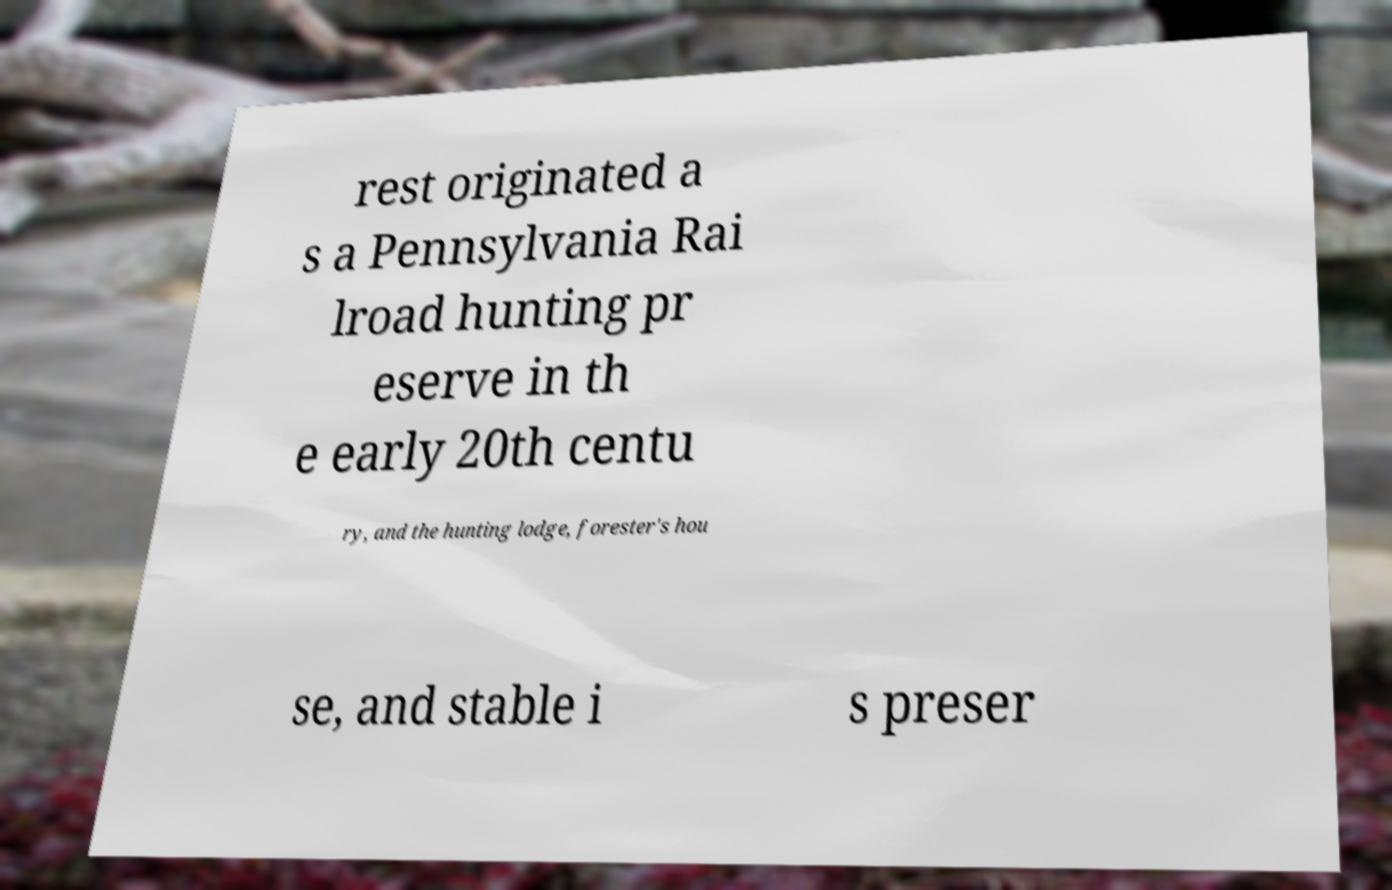What messages or text are displayed in this image? I need them in a readable, typed format. rest originated a s a Pennsylvania Rai lroad hunting pr eserve in th e early 20th centu ry, and the hunting lodge, forester's hou se, and stable i s preser 